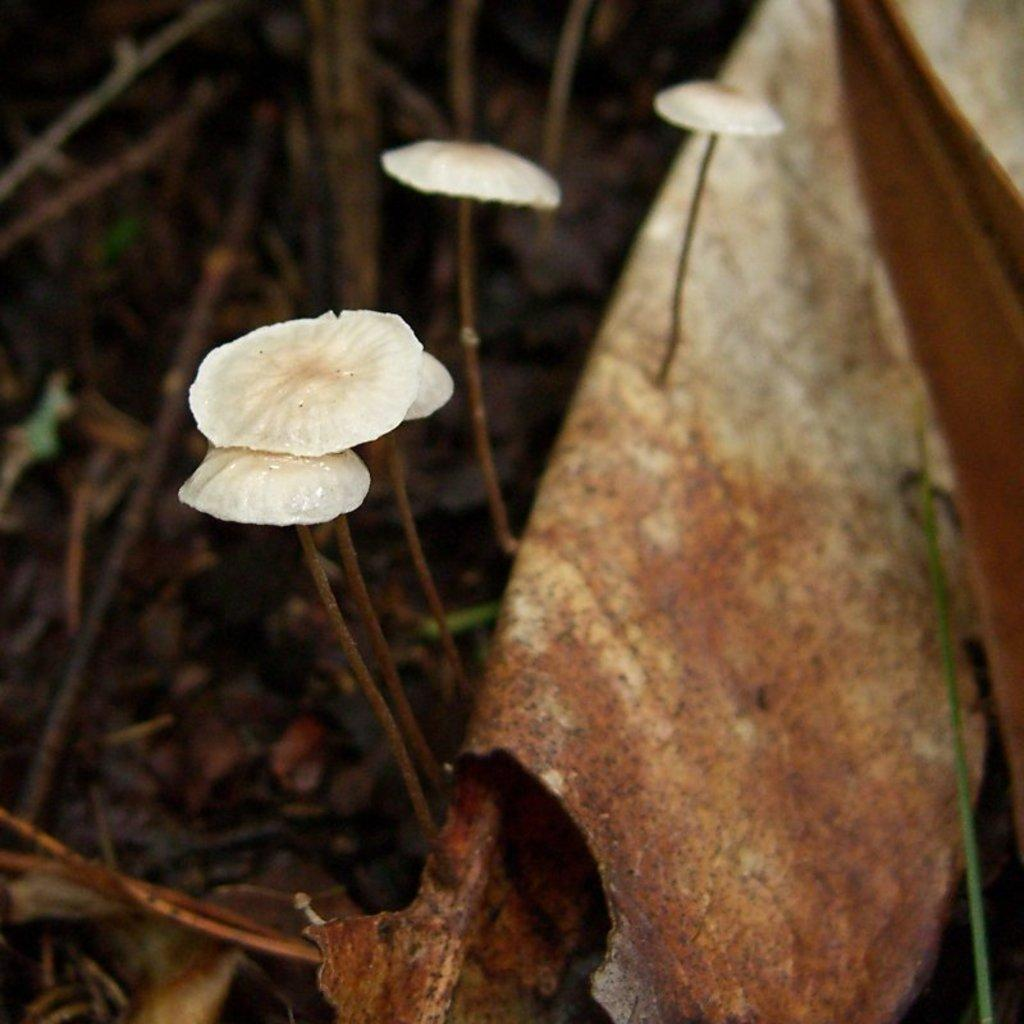What is located on the right side of the image in the foreground? There is a leaf in the foreground of the image on the right side. What can be seen in the middle of the image? There are mushrooms in the middle of the image. What is present on the ground in the background of the image? There are sticks on the ground in the background of the image. What type of rail can be seen in the image? There is no rail present in the image; it features a leaf, mushrooms, and sticks. Is there a locket hanging from the leaf in the image? There is no locket present in the image; it only features a leaf, mushrooms, and sticks. 